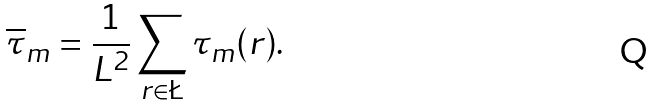Convert formula to latex. <formula><loc_0><loc_0><loc_500><loc_500>\overline { \tau } _ { m } = \frac { 1 } { L ^ { 2 } } \sum _ { r \in \L } \tau _ { m } ( r ) .</formula> 